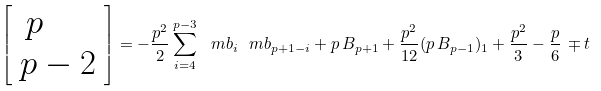<formula> <loc_0><loc_0><loc_500><loc_500>\left [ \begin{array} { l } \, p \\ p - 2 \end{array} \right ] = - \frac { p ^ { 2 } } { 2 } \sum _ { i = 4 } ^ { p - 3 } \ m b _ { i } \ m b _ { p + 1 - i } + p \, B _ { p + 1 } + \frac { p ^ { 2 } } { 1 2 } ( p \, B _ { p - 1 } ) _ { 1 } + \frac { p ^ { 2 } } { 3 } - \frac { p } { 6 } \, \mp t</formula> 